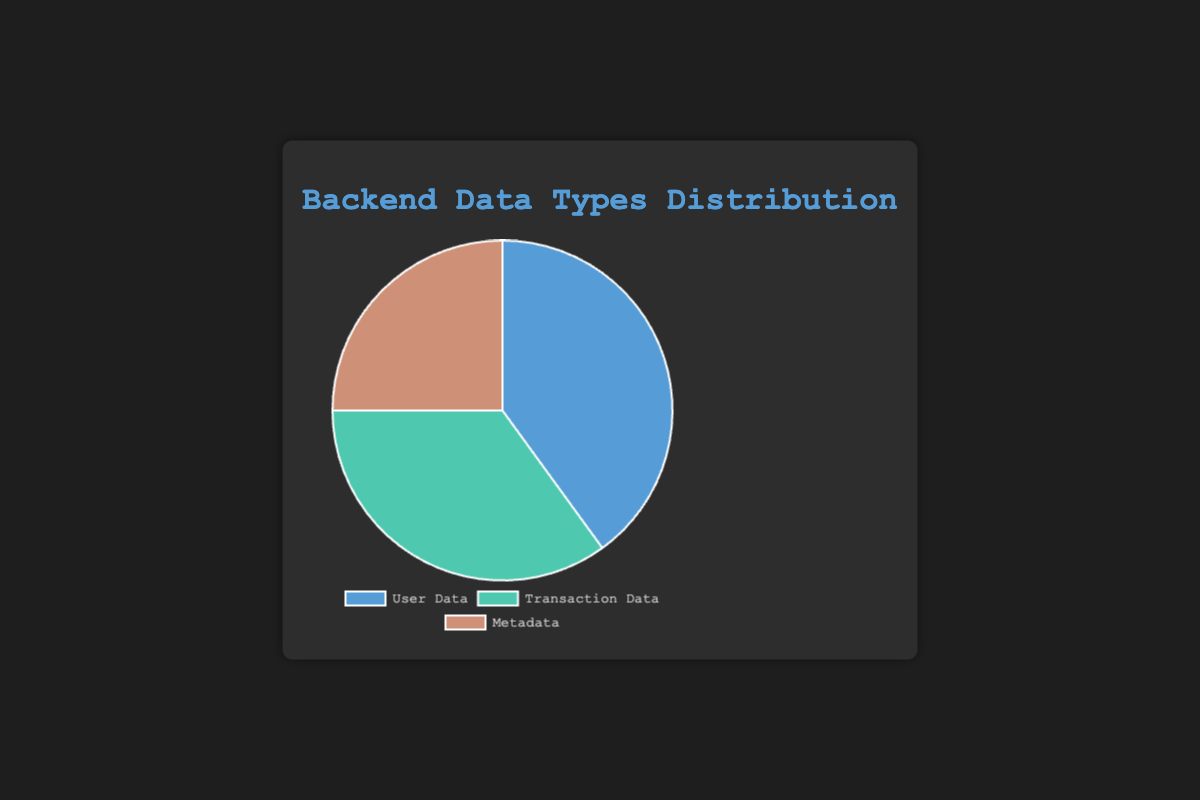What percentage of data is not Transaction Data? To find what percentage of the data is not Transaction Data, subtract the percentage of Transaction Data from 100%. Since Transaction Data is 35%, the calculation is 100% - 35% = 65%.
Answer: 65% What is the difference in percentage between User Data and Metadata? Subtract the percentage of Metadata from the percentage of User Data. User Data is 40%, and Metadata is 25%, so 40% - 25% = 15%.
Answer: 15% What type of data has the second-largest percentage? In the figure, User Data has 40%, Transaction Data has 35%, and Metadata has 25%. The second-largest percentage is 35%, which corresponds to Transaction Data.
Answer: Transaction Data Which segment in the pie chart is the smallest? According to the data, Metadata accounts for 25%, which is the smallest percentage among the data types in the chart.
Answer: Metadata What is the combined percentage of User Data and Transaction Data? Add the percentages of User Data and Transaction Data. User Data is 40%, and Transaction Data is 35%, so the calculation is 40% + 35% = 75%.
Answer: 75% Which data type occupies the largest portion of the pie chart? User Data occupies 40%, which is the largest single portion compared to Transaction Data (35%) and Metadata (25%).
Answer: User Data How much greater is User Data compared to Transaction Data in percentage points? Subtract the percentage of Transaction Data from User Data. User Data is 40%, and Transaction Data is 35%, so 40% - 35% = 5%.
Answer: 5% What color represents Metadata in the pie chart? According to the figure, Metadata is represented by the color brownish (described in the code as `#ce9178`).
Answer: Brownish If you were to combine Metadata and Transaction Data, what fraction of the chart would that represent? Add the percentages of Metadata and Transaction Data. Metadata is 25% and Transaction Data is 35%, thus 25% + 35% = 60%. This represents 60% of the pie chart.
Answer: 60% 